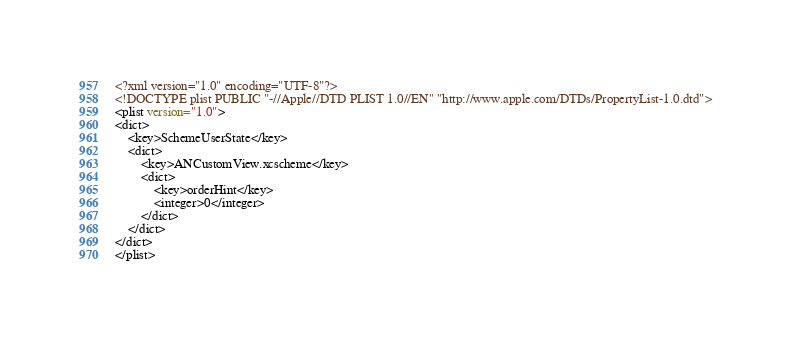<code> <loc_0><loc_0><loc_500><loc_500><_XML_><?xml version="1.0" encoding="UTF-8"?>
<!DOCTYPE plist PUBLIC "-//Apple//DTD PLIST 1.0//EN" "http://www.apple.com/DTDs/PropertyList-1.0.dtd">
<plist version="1.0">
<dict>
	<key>SchemeUserState</key>
	<dict>
		<key>ANCustomView.xcscheme</key>
		<dict>
			<key>orderHint</key>
			<integer>0</integer>
		</dict>
	</dict>
</dict>
</plist>
</code> 